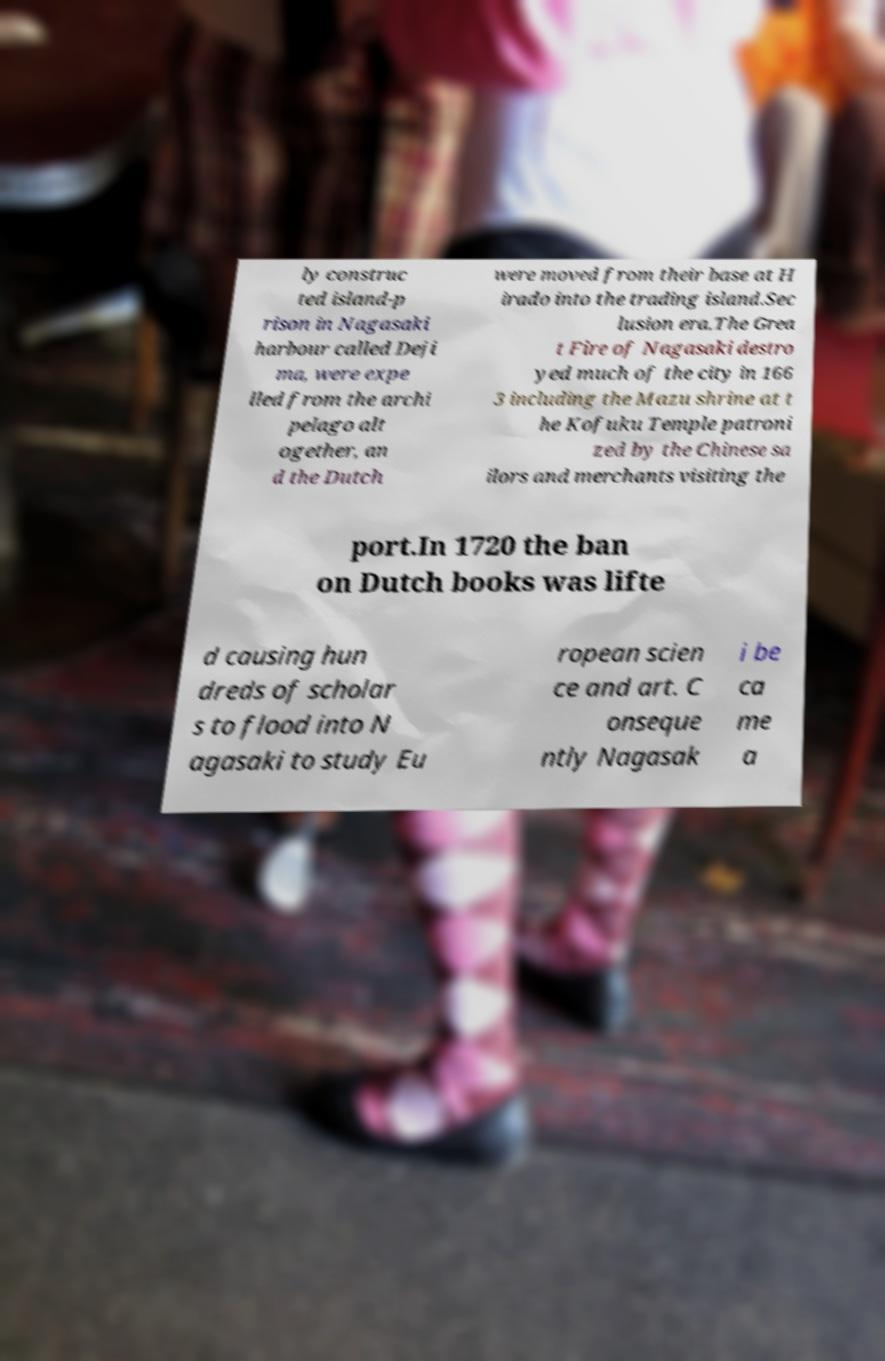I need the written content from this picture converted into text. Can you do that? ly construc ted island-p rison in Nagasaki harbour called Deji ma, were expe lled from the archi pelago alt ogether, an d the Dutch were moved from their base at H irado into the trading island.Sec lusion era.The Grea t Fire of Nagasaki destro yed much of the city in 166 3 including the Mazu shrine at t he Kofuku Temple patroni zed by the Chinese sa ilors and merchants visiting the port.In 1720 the ban on Dutch books was lifte d causing hun dreds of scholar s to flood into N agasaki to study Eu ropean scien ce and art. C onseque ntly Nagasak i be ca me a 